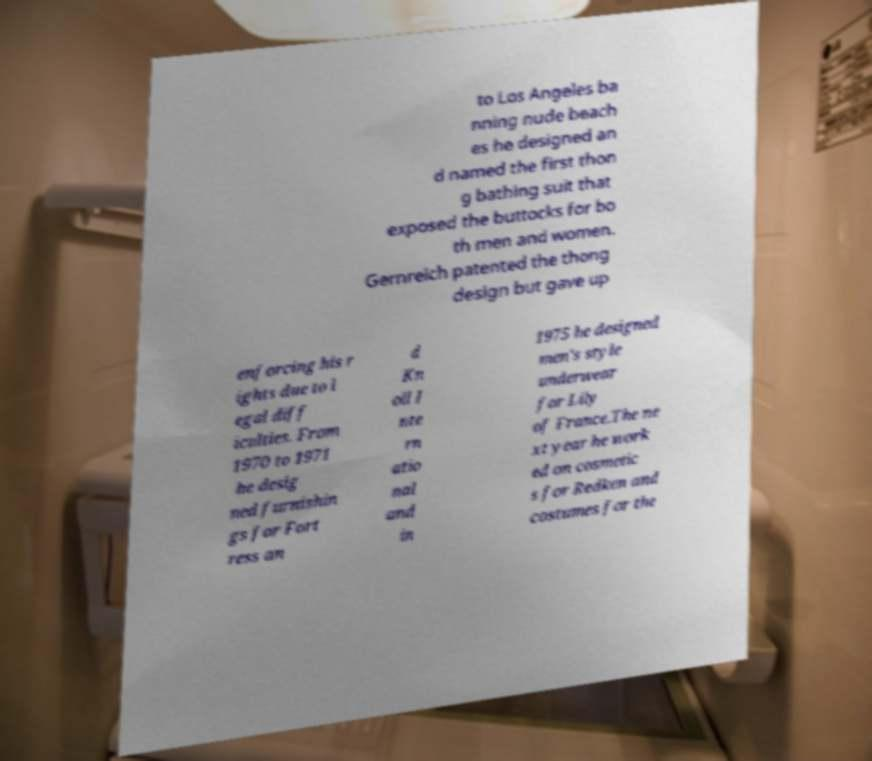I need the written content from this picture converted into text. Can you do that? to Los Angeles ba nning nude beach es he designed an d named the first thon g bathing suit that exposed the buttocks for bo th men and women. Gernreich patented the thong design but gave up enforcing his r ights due to l egal diff iculties. From 1970 to 1971 he desig ned furnishin gs for Fort ress an d Kn oll I nte rn atio nal and in 1975 he designed men's style underwear for Lily of France.The ne xt year he work ed on cosmetic s for Redken and costumes for the 